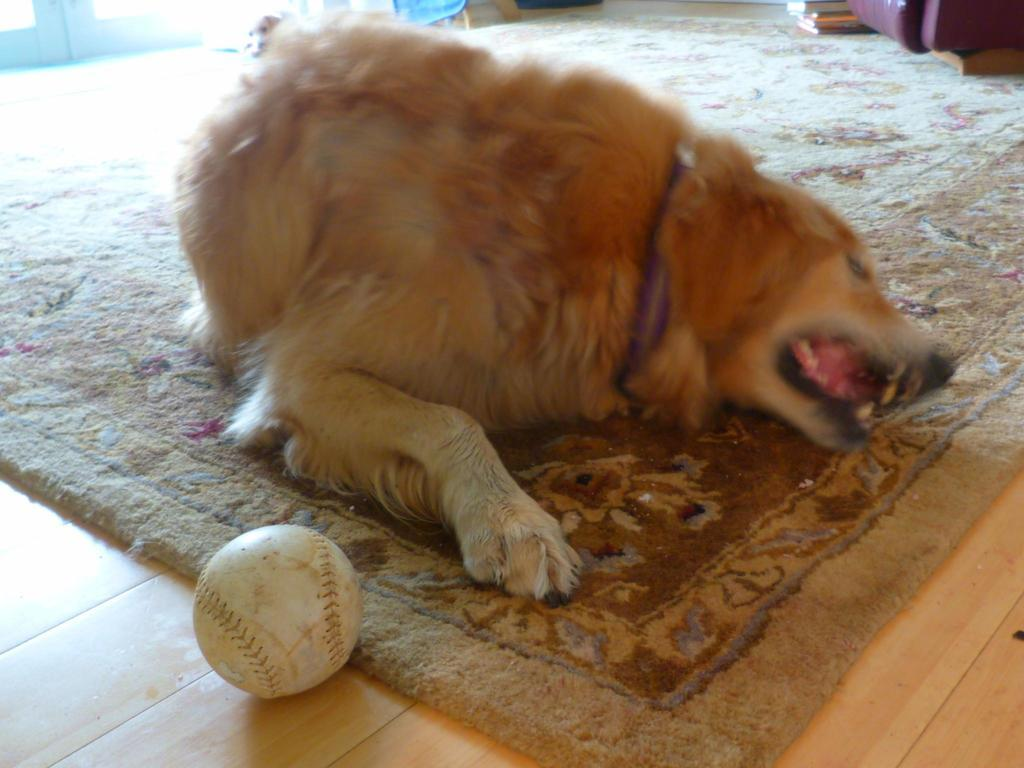What type of animal can be seen on the carpet in the image? There is a dog on the carpet in the image. What object is located on the floor in the bottom left side of the image? There is a ball on the floor in the bottom left side of the image. Can you describe the position of the second dog in the image? There is another dog on the top left side of the image. How many cakes are present on the mountain in the image? There are no cakes or mountains present in the image; it features two dogs and a ball. What type of flock is visible in the image? There is no flock visible in the image; it features two dogs and a ball. 